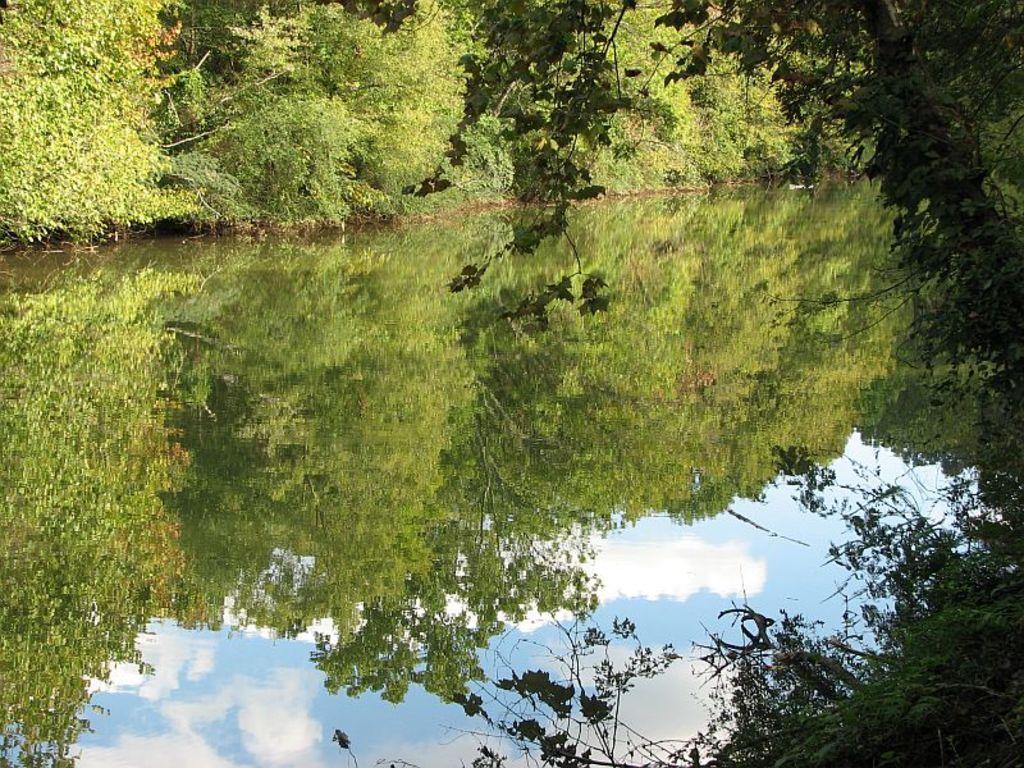In one or two sentences, can you explain what this image depicts? In this image, we can see the water. On the water, we can see some reflections. Here we can see trees and sky. On the right side and top of the image, we can see so many trees and plants. 